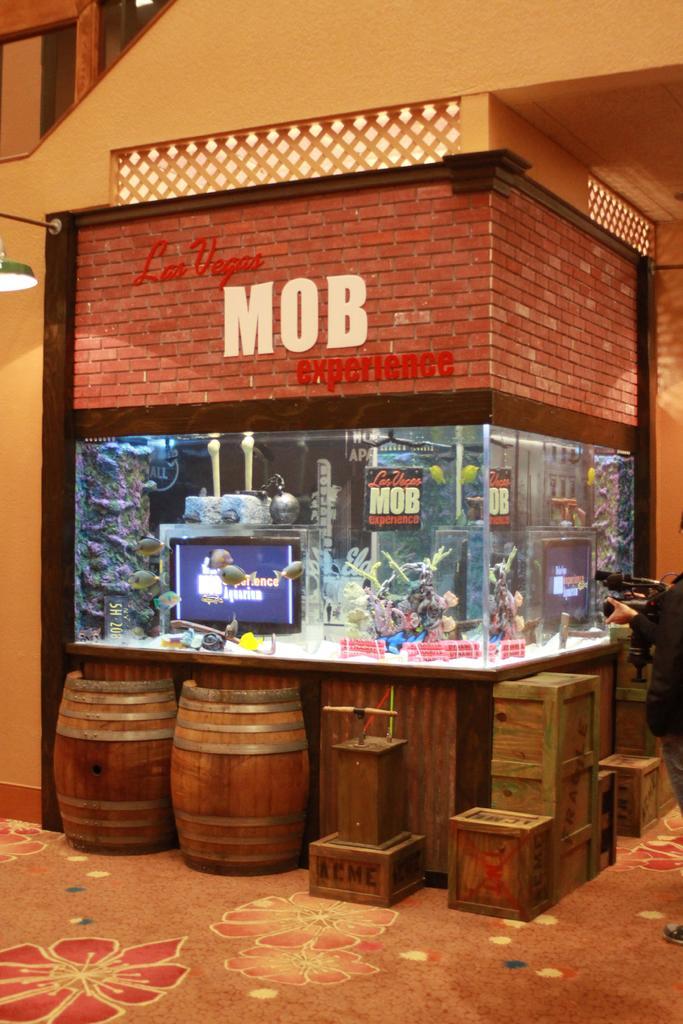In one or two sentences, can you explain what this image depicts? In this image I can see a building , in front of the building I can see boxes and drums kept on the floor.. 